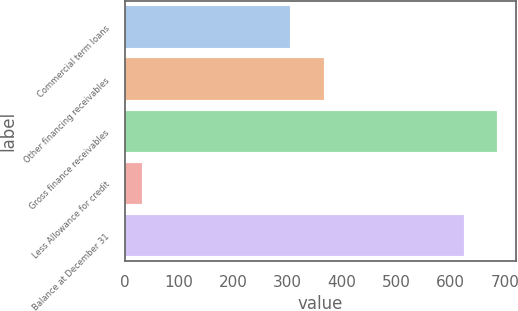Convert chart to OTSL. <chart><loc_0><loc_0><loc_500><loc_500><bar_chart><fcel>Commercial term loans<fcel>Other financing receivables<fcel>Gross finance receivables<fcel>Less Allowance for credit<fcel>Balance at December 31<nl><fcel>305<fcel>367.4<fcel>686.4<fcel>31<fcel>624<nl></chart> 